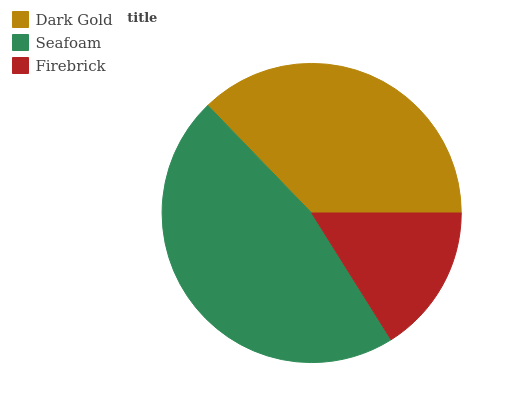Is Firebrick the minimum?
Answer yes or no. Yes. Is Seafoam the maximum?
Answer yes or no. Yes. Is Seafoam the minimum?
Answer yes or no. No. Is Firebrick the maximum?
Answer yes or no. No. Is Seafoam greater than Firebrick?
Answer yes or no. Yes. Is Firebrick less than Seafoam?
Answer yes or no. Yes. Is Firebrick greater than Seafoam?
Answer yes or no. No. Is Seafoam less than Firebrick?
Answer yes or no. No. Is Dark Gold the high median?
Answer yes or no. Yes. Is Dark Gold the low median?
Answer yes or no. Yes. Is Seafoam the high median?
Answer yes or no. No. Is Firebrick the low median?
Answer yes or no. No. 